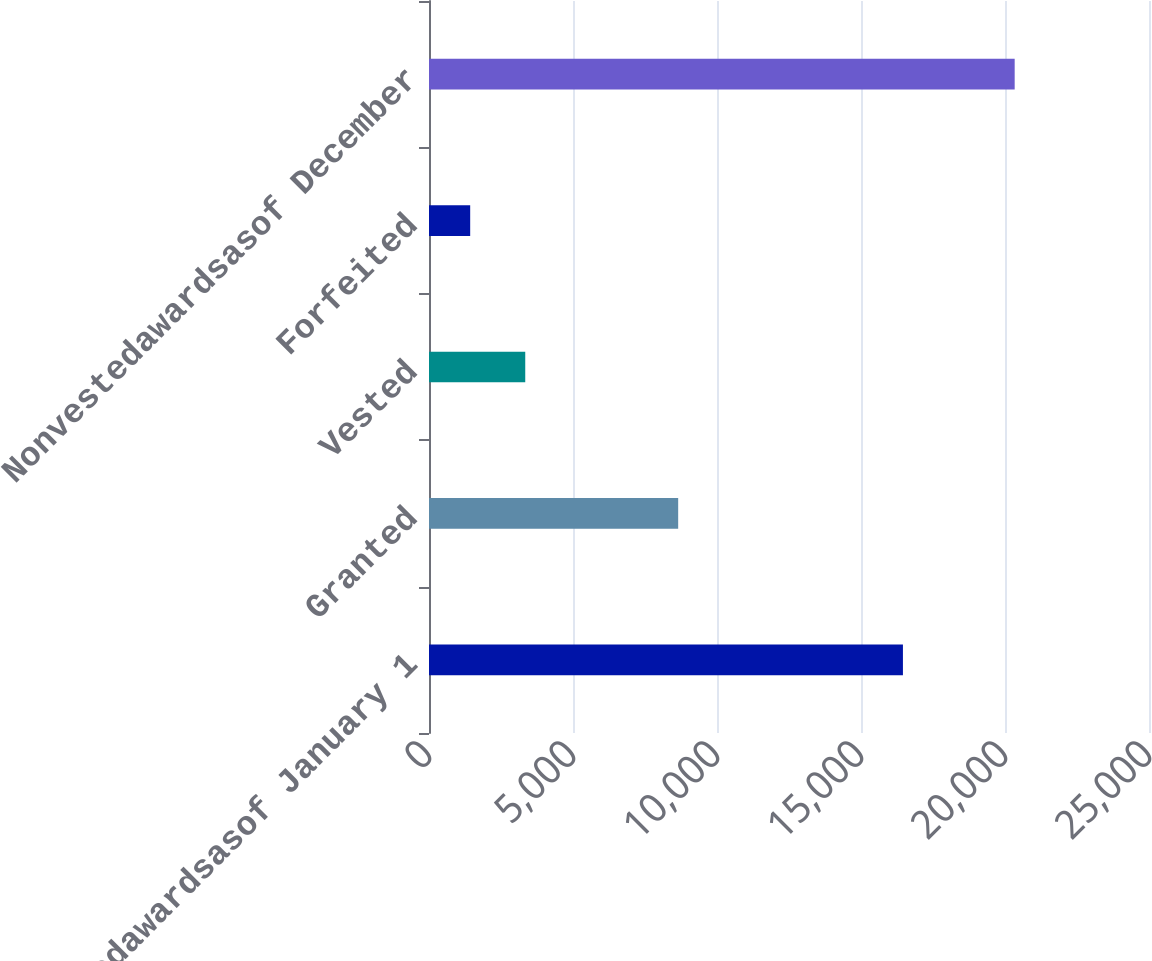Convert chart to OTSL. <chart><loc_0><loc_0><loc_500><loc_500><bar_chart><fcel>Nonvestedawardsasof January 1<fcel>Granted<fcel>Vested<fcel>Forfeited<fcel>Nonvestedawardsasof December<nl><fcel>16456<fcel>8652<fcel>3342<fcel>1430<fcel>20336<nl></chart> 